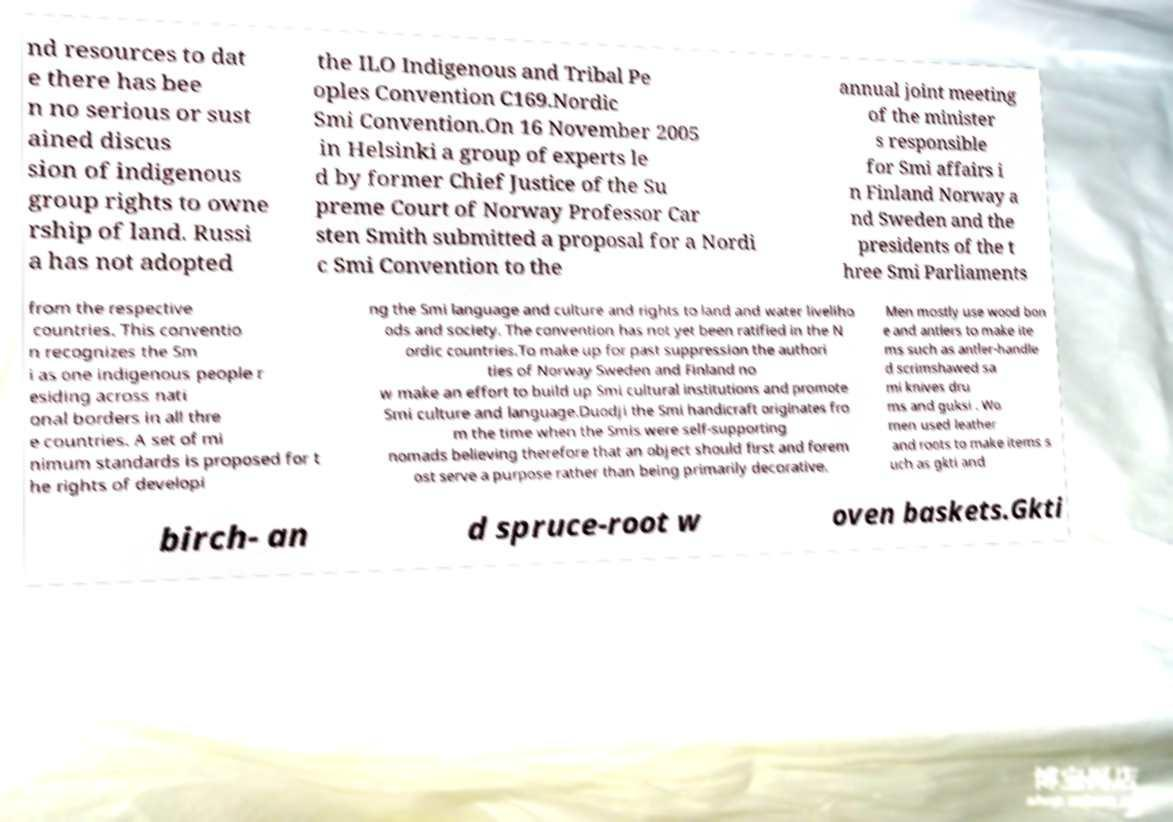Please identify and transcribe the text found in this image. nd resources to dat e there has bee n no serious or sust ained discus sion of indigenous group rights to owne rship of land. Russi a has not adopted the ILO Indigenous and Tribal Pe oples Convention C169.Nordic Smi Convention.On 16 November 2005 in Helsinki a group of experts le d by former Chief Justice of the Su preme Court of Norway Professor Car sten Smith submitted a proposal for a Nordi c Smi Convention to the annual joint meeting of the minister s responsible for Smi affairs i n Finland Norway a nd Sweden and the presidents of the t hree Smi Parliaments from the respective countries. This conventio n recognizes the Sm i as one indigenous people r esiding across nati onal borders in all thre e countries. A set of mi nimum standards is proposed for t he rights of developi ng the Smi language and culture and rights to land and water liveliho ods and society. The convention has not yet been ratified in the N ordic countries.To make up for past suppression the authori ties of Norway Sweden and Finland no w make an effort to build up Smi cultural institutions and promote Smi culture and language.Duodji the Smi handicraft originates fro m the time when the Smis were self-supporting nomads believing therefore that an object should first and forem ost serve a purpose rather than being primarily decorative. Men mostly use wood bon e and antlers to make ite ms such as antler-handle d scrimshawed sa mi knives dru ms and guksi . Wo men used leather and roots to make items s uch as gkti and birch- an d spruce-root w oven baskets.Gkti 